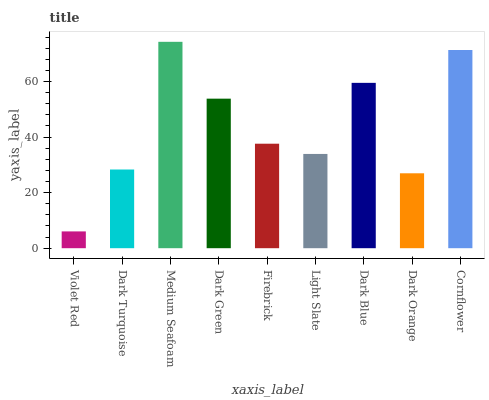Is Violet Red the minimum?
Answer yes or no. Yes. Is Medium Seafoam the maximum?
Answer yes or no. Yes. Is Dark Turquoise the minimum?
Answer yes or no. No. Is Dark Turquoise the maximum?
Answer yes or no. No. Is Dark Turquoise greater than Violet Red?
Answer yes or no. Yes. Is Violet Red less than Dark Turquoise?
Answer yes or no. Yes. Is Violet Red greater than Dark Turquoise?
Answer yes or no. No. Is Dark Turquoise less than Violet Red?
Answer yes or no. No. Is Firebrick the high median?
Answer yes or no. Yes. Is Firebrick the low median?
Answer yes or no. Yes. Is Dark Green the high median?
Answer yes or no. No. Is Violet Red the low median?
Answer yes or no. No. 